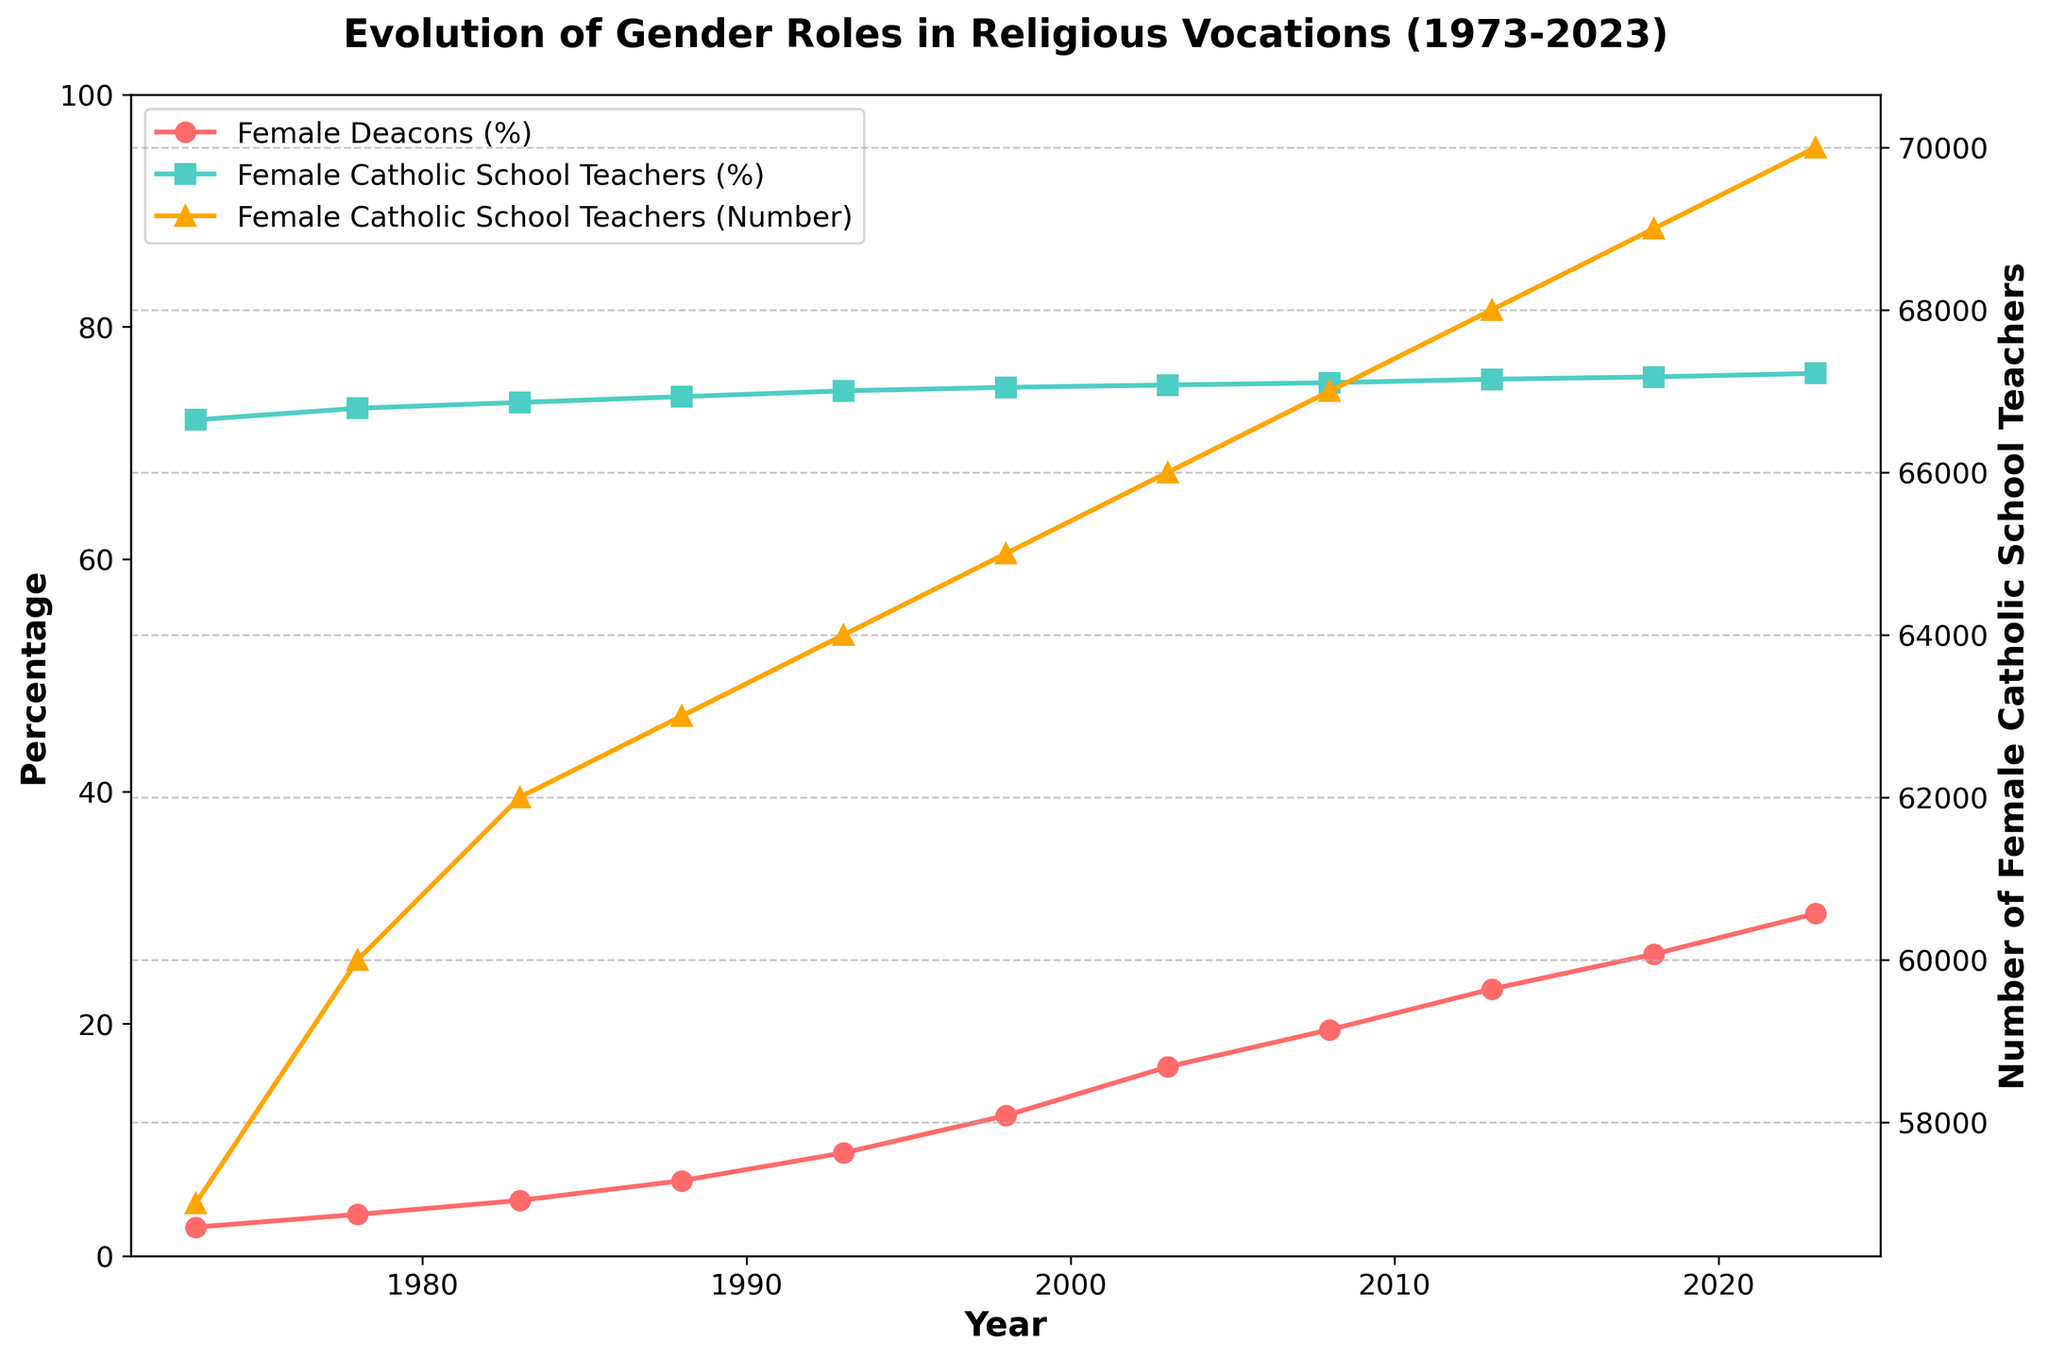What is the title of the chart? The title of the chart is located at the top and usually summarizes the main topic that the chart aims to depict.
Answer: Evolution of Gender Roles in Religious Vocations (1973-2023) How many data points are there for the percentage of Female Deacons? To find the number of data points for the percentage of Female Deacons, count the points represented on the line plot for Female Deacons (%).
Answer: 11 Which role has the highest percentage at any given time? Observing the highest points in the chart for each line plot, we see the highest percentage for Female Catholic School Teachers in comparison to Female Deacons.
Answer: Female Catholic School Teachers In which year did the percentage of Female Deacons first exceed 20%? Locate the point on the Female Deacons (%) line plot where the y-value first exceeds 20%. This occurs in the year 2013.
Answer: 2013 What is the percentage increase of Female Deacons from 1973 to 2023? The percentage of Female Deacons in 2023 minus the percentage in 1973 gives the increase. (29.5% - 2.5%) = 27%.
Answer: 27% How many Female Catholic School Teachers were there in 1983? Refer to the line plot with the triangles representing the number of Female Catholic School Teachers and find the value for the year 1983.
Answer: 62000 What is the average percentage of Female Deacons over the recorded period? To find the average, sum the percentages of Female Deacons for all years and divide by the total number of years (2.5 + 3.6 + 4.8 + 6.5 + 8.9 + 12.1 + 16.3 + 19.5 + 23.0 + 26.0 + 29.5) / 11 ≈ 13.5%.
Answer: 13.5% By how much did the number of Female Catholic School Teachers increase from 1973 to 2023? Subtract the number of Female Catholic School Teachers in 1973 from the number in 2023 (70000 - 57000) = 13000.
Answer: 13000 Is the trend of Female Deacons' percentage increasing or decreasing? Examine the slope of the line plot for Female Deacons (%). Since the line plot has an upward trajectory, the trend is increasing.
Answer: Increasing In what year did the percentage of Female Catholic School Teachers reach 75%? Locate the point on the plot for Female Catholic School Teachers (%) where it first hits 75%. This occurred in the year 2003.
Answer: 2003 